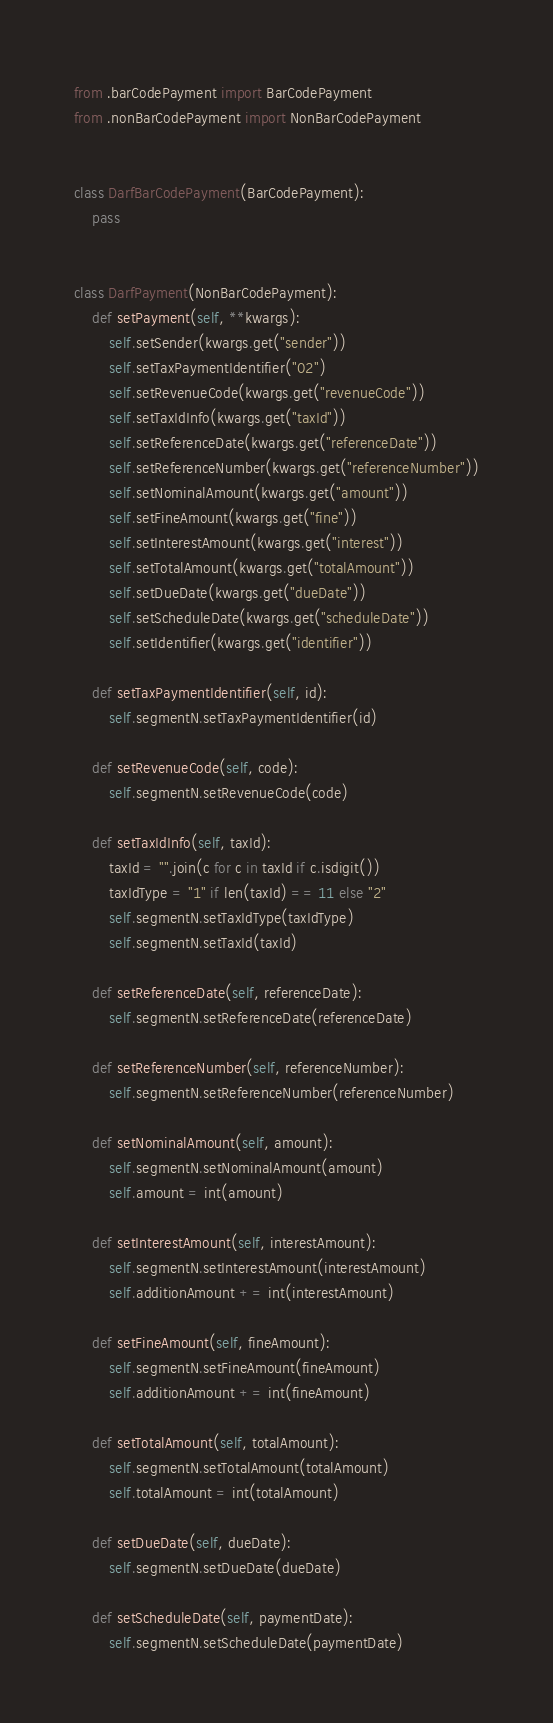Convert code to text. <code><loc_0><loc_0><loc_500><loc_500><_Python_>from .barCodePayment import BarCodePayment
from .nonBarCodePayment import NonBarCodePayment


class DarfBarCodePayment(BarCodePayment):
    pass


class DarfPayment(NonBarCodePayment):
    def setPayment(self, **kwargs):
        self.setSender(kwargs.get("sender"))
        self.setTaxPaymentIdentifier("02")
        self.setRevenueCode(kwargs.get("revenueCode"))
        self.setTaxIdInfo(kwargs.get("taxId"))
        self.setReferenceDate(kwargs.get("referenceDate"))
        self.setReferenceNumber(kwargs.get("referenceNumber"))
        self.setNominalAmount(kwargs.get("amount"))
        self.setFineAmount(kwargs.get("fine"))
        self.setInterestAmount(kwargs.get("interest"))
        self.setTotalAmount(kwargs.get("totalAmount"))
        self.setDueDate(kwargs.get("dueDate"))
        self.setScheduleDate(kwargs.get("scheduleDate"))
        self.setIdentifier(kwargs.get("identifier"))

    def setTaxPaymentIdentifier(self, id):
        self.segmentN.setTaxPaymentIdentifier(id)

    def setRevenueCode(self, code):
        self.segmentN.setRevenueCode(code)

    def setTaxIdInfo(self, taxId):
        taxId = "".join(c for c in taxId if c.isdigit())
        taxIdType = "1" if len(taxId) == 11 else "2"
        self.segmentN.setTaxIdType(taxIdType)
        self.segmentN.setTaxId(taxId)

    def setReferenceDate(self, referenceDate):
        self.segmentN.setReferenceDate(referenceDate)

    def setReferenceNumber(self, referenceNumber):
        self.segmentN.setReferenceNumber(referenceNumber)

    def setNominalAmount(self, amount):
        self.segmentN.setNominalAmount(amount)
        self.amount = int(amount)

    def setInterestAmount(self, interestAmount):
        self.segmentN.setInterestAmount(interestAmount)
        self.additionAmount += int(interestAmount)

    def setFineAmount(self, fineAmount):
        self.segmentN.setFineAmount(fineAmount)
        self.additionAmount += int(fineAmount)

    def setTotalAmount(self, totalAmount):
        self.segmentN.setTotalAmount(totalAmount)
        self.totalAmount = int(totalAmount)

    def setDueDate(self, dueDate):
        self.segmentN.setDueDate(dueDate)

    def setScheduleDate(self, paymentDate):
        self.segmentN.setScheduleDate(paymentDate)
</code> 